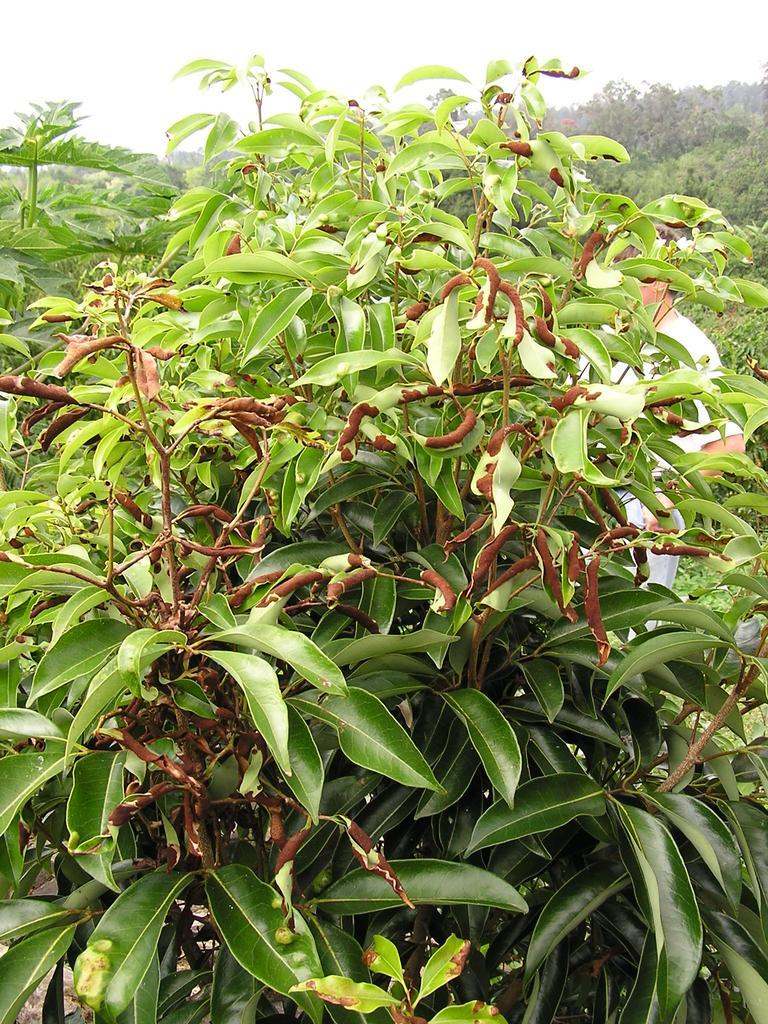What is the dominant color in the image? The image contains a lot of greenery. Can you describe the person in the image? There is a man standing in the image. What is the man wearing? The man is wearing white attire. Where is the queen sitting in the image? There is no queen present in the image. How many cows can be seen grazing in the greenery? There are no cows visible in the image; it contains only greenery and a man. 